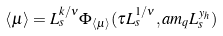Convert formula to latex. <formula><loc_0><loc_0><loc_500><loc_500>\langle \mu \rangle = L _ { s } ^ { k / \nu } \Phi _ { \langle \mu \rangle } ( \tau L _ { s } ^ { 1 / \nu } , a m _ { q } L _ { s } ^ { y _ { h } } )</formula> 